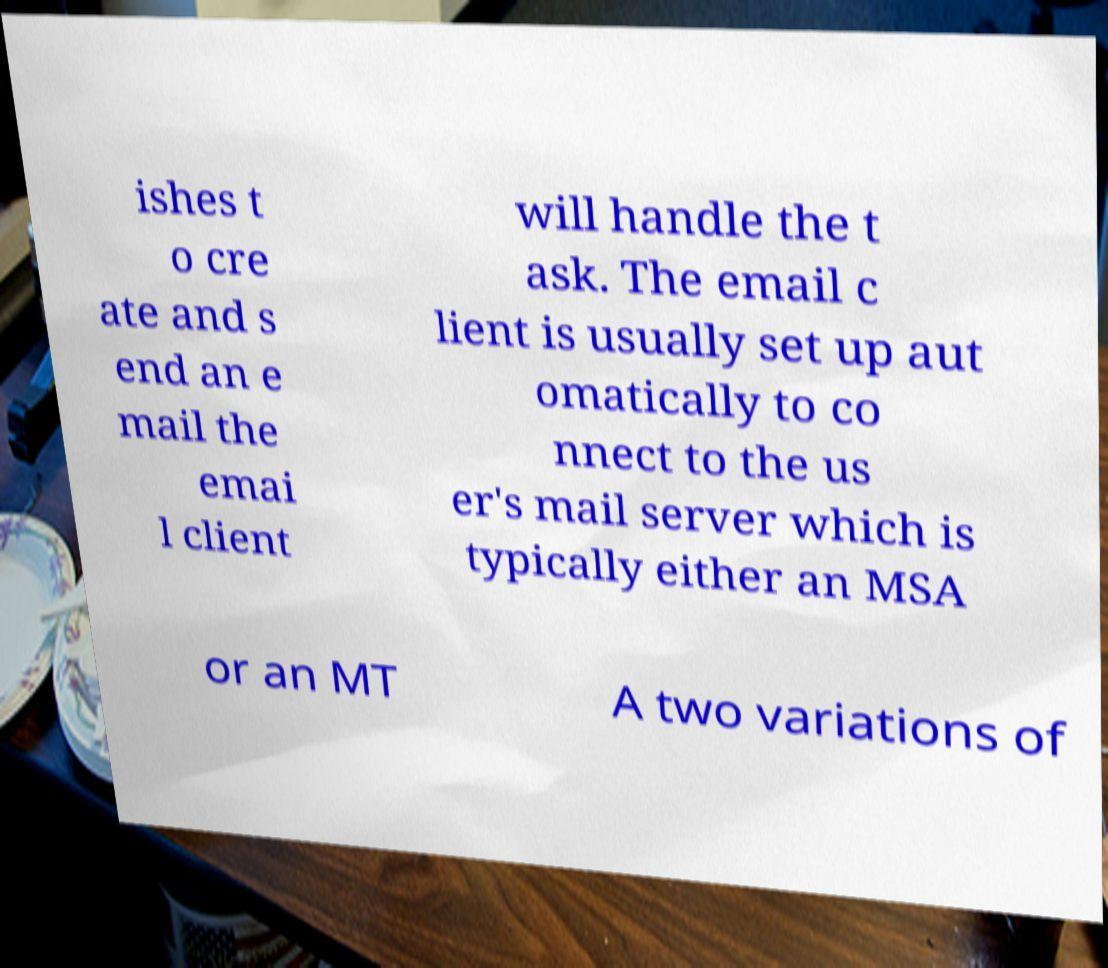Can you read and provide the text displayed in the image?This photo seems to have some interesting text. Can you extract and type it out for me? ishes t o cre ate and s end an e mail the emai l client will handle the t ask. The email c lient is usually set up aut omatically to co nnect to the us er's mail server which is typically either an MSA or an MT A two variations of 